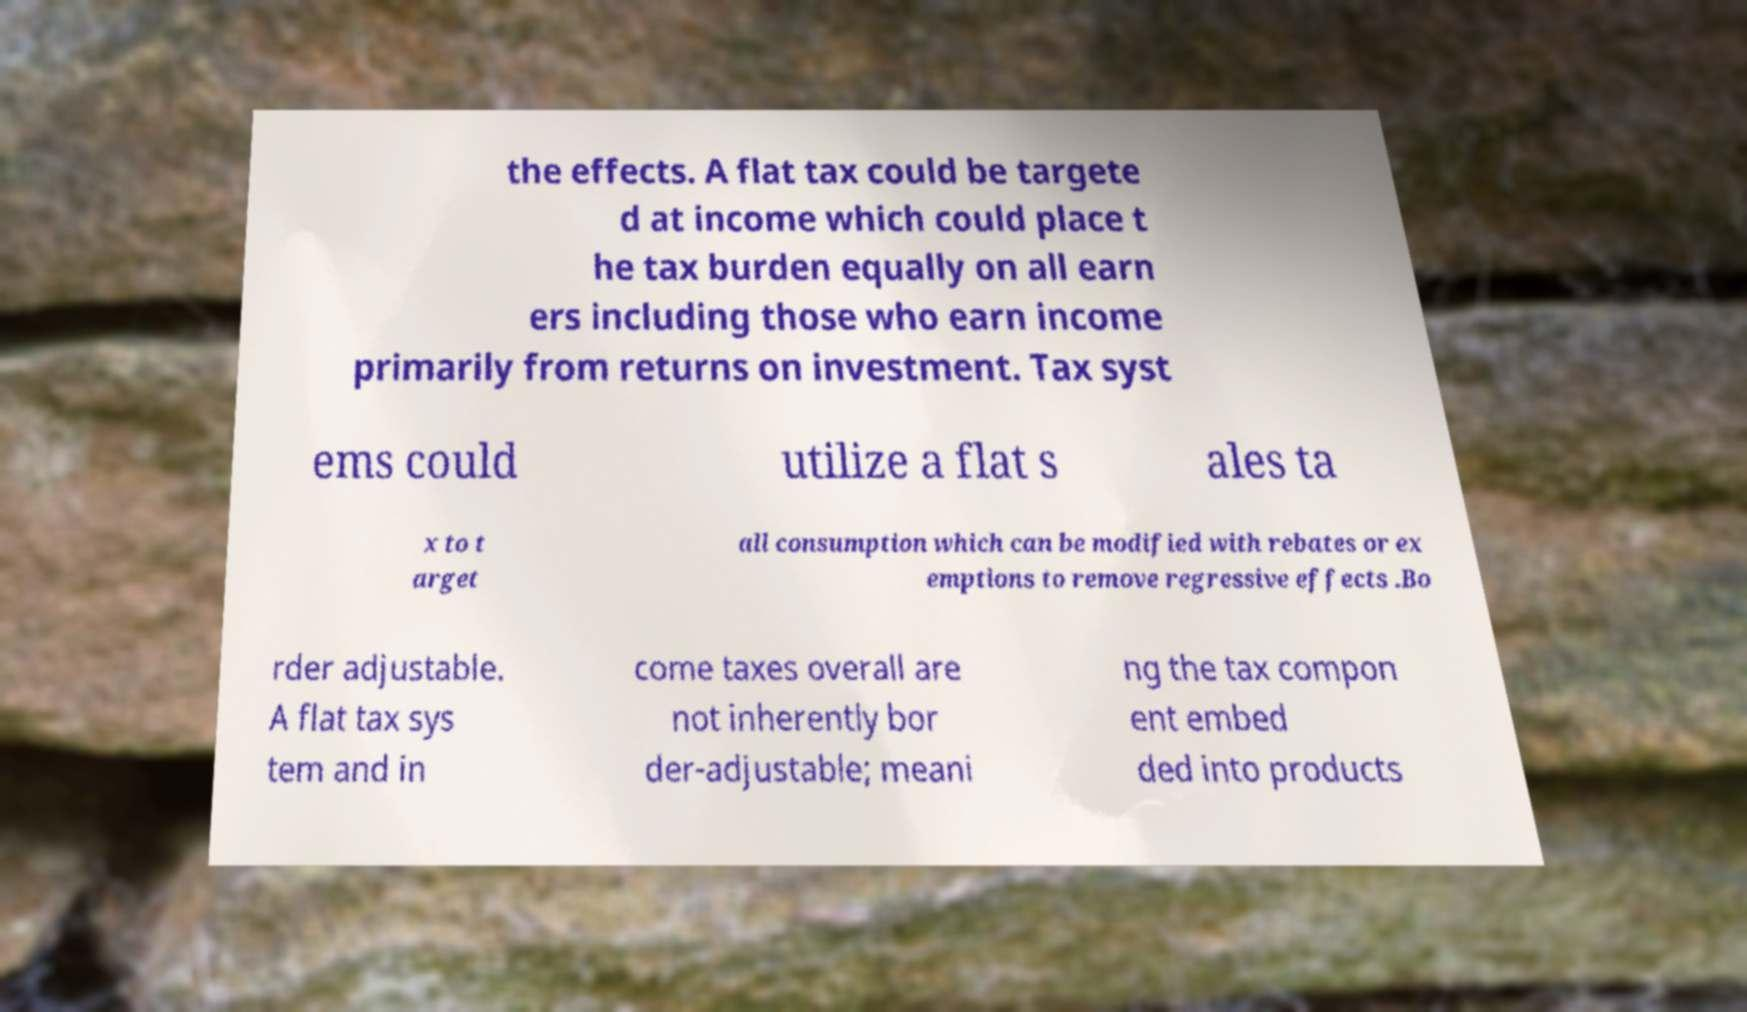Can you read and provide the text displayed in the image?This photo seems to have some interesting text. Can you extract and type it out for me? the effects. A flat tax could be targete d at income which could place t he tax burden equally on all earn ers including those who earn income primarily from returns on investment. Tax syst ems could utilize a flat s ales ta x to t arget all consumption which can be modified with rebates or ex emptions to remove regressive effects .Bo rder adjustable. A flat tax sys tem and in come taxes overall are not inherently bor der-adjustable; meani ng the tax compon ent embed ded into products 